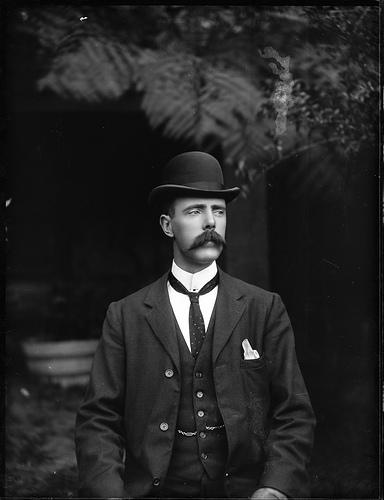What kind of hat is the gentleman wearing?
Write a very short answer. Bowler. Is the man wearing a hat?
Keep it brief. Yes. Is this man wearing contact lenses?
Quick response, please. No. Is this man wearing a necktie?
Write a very short answer. Yes. Are there visual clues that date this photo?
Concise answer only. Yes. What type of hat is the man wearing?
Quick response, please. Top hat. Does this man have facial hair?
Concise answer only. Yes. On which lapel is the gentleman wearing a flower?
Short answer required. Left. 